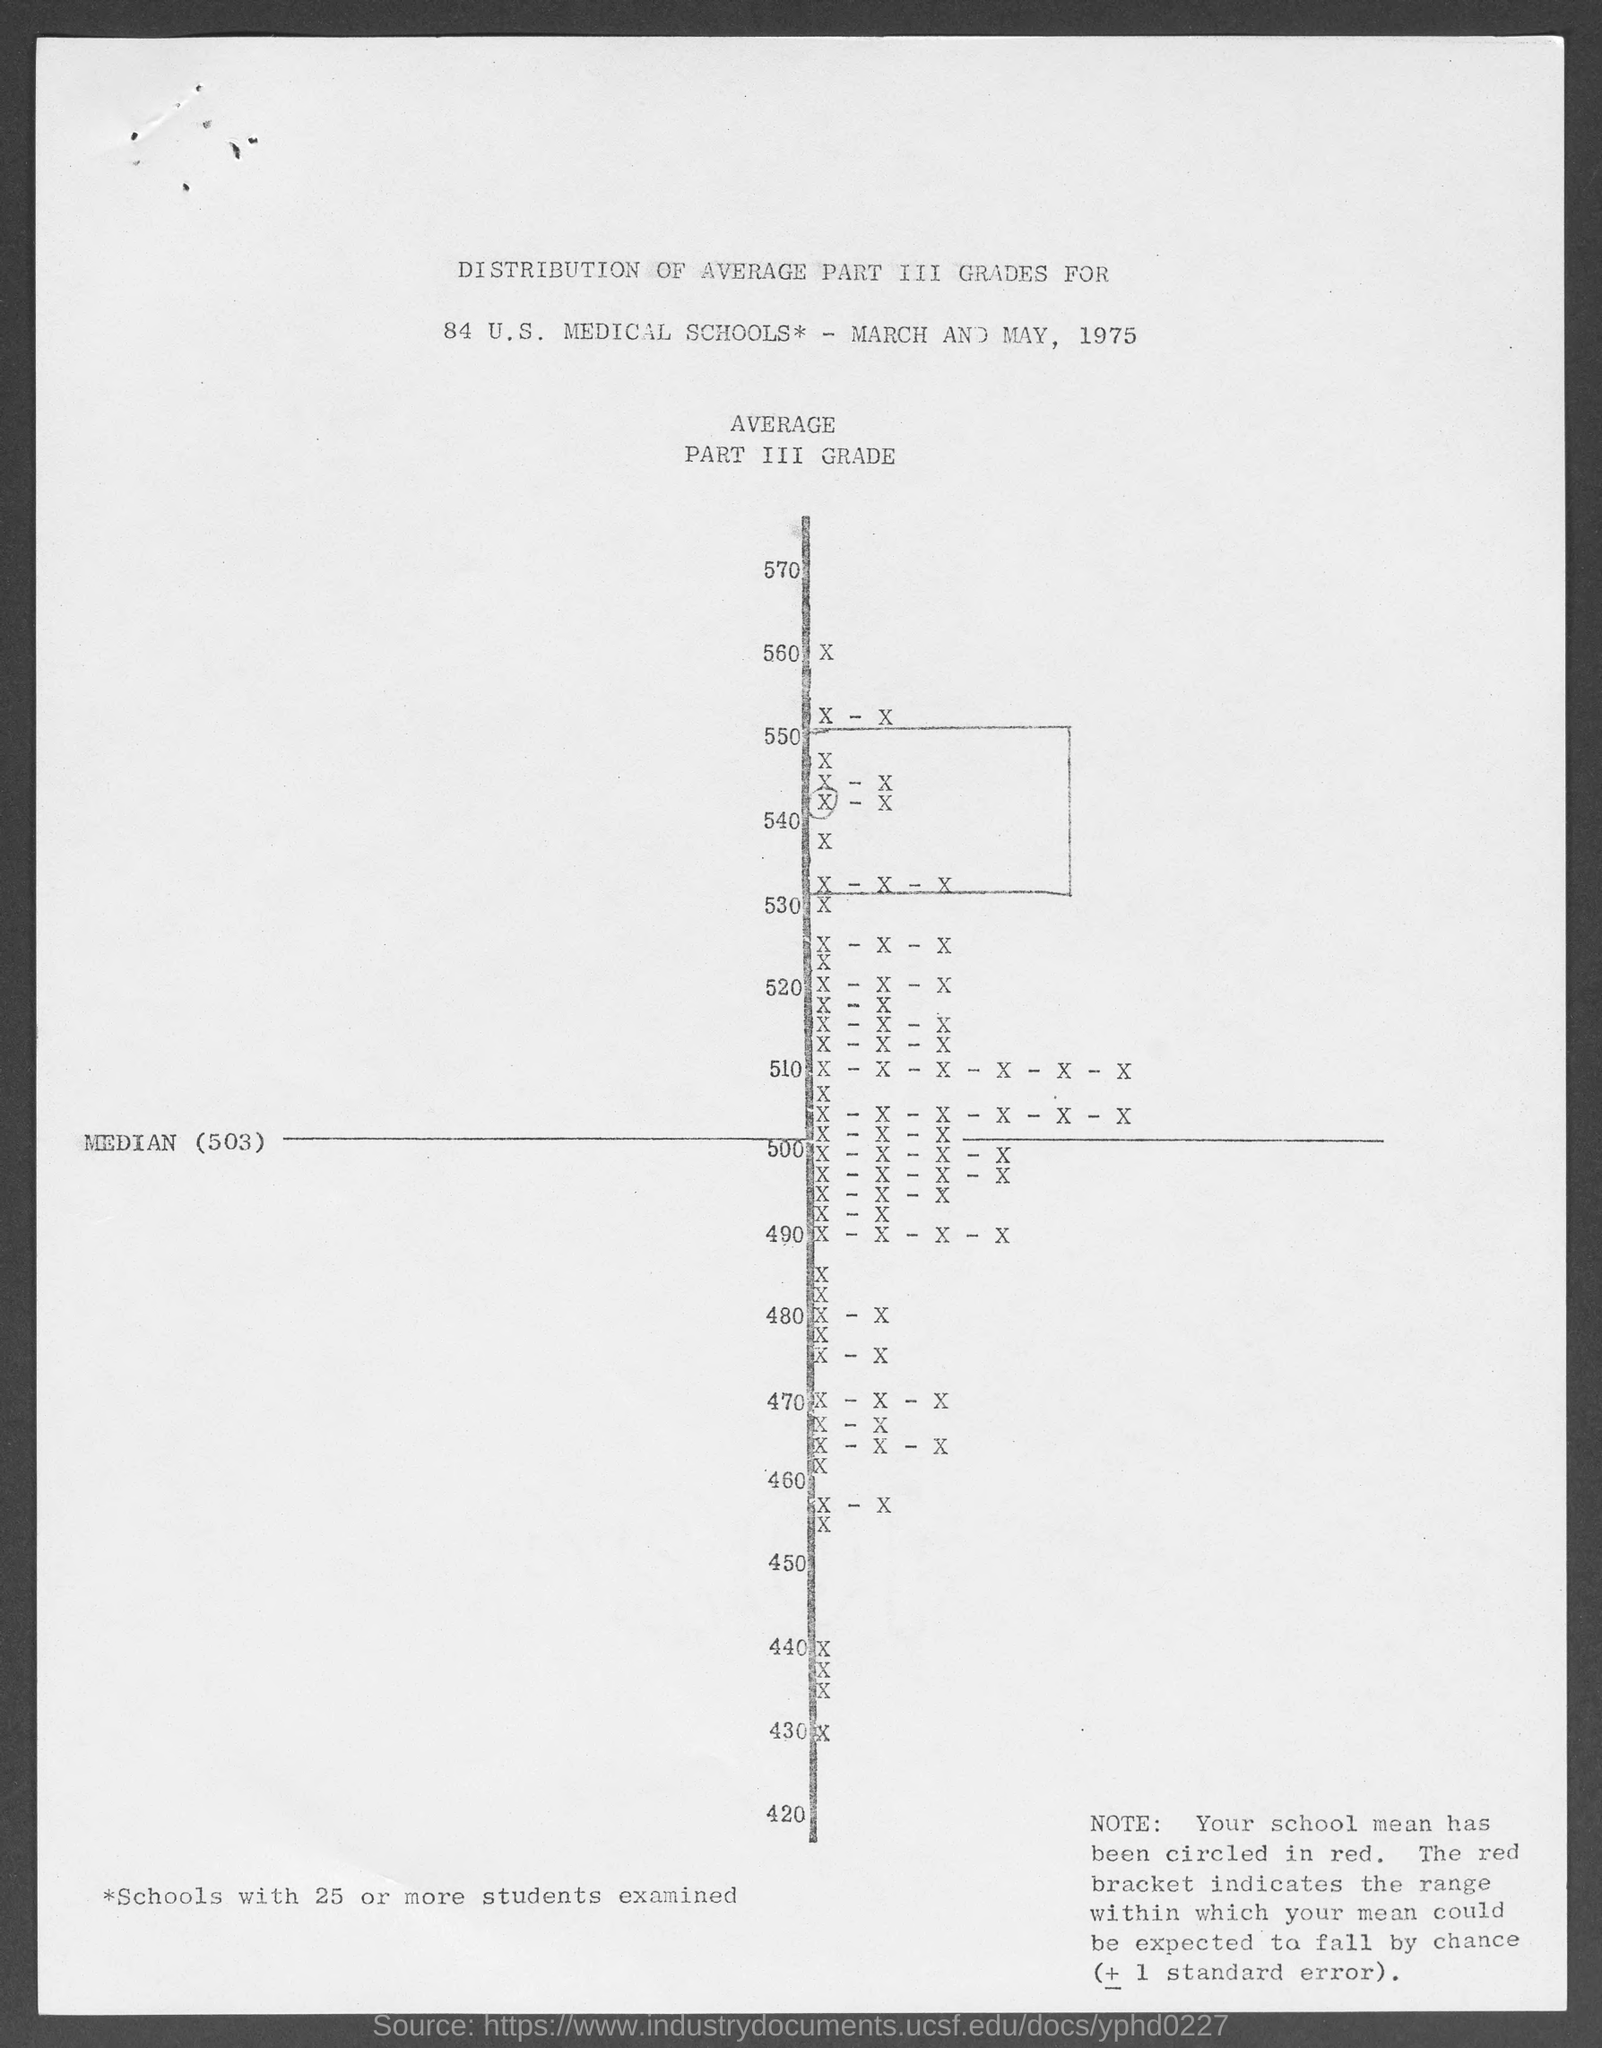Mention a couple of crucial points in this snapshot. The lowest value is 420. The median value is 503. The year depicted in the document is 1975. The highest value is 570. 